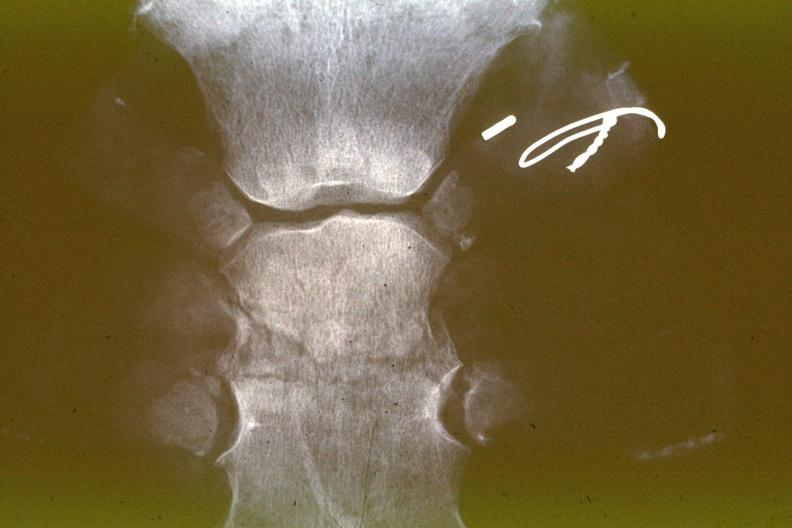does this image show x-ray sternum healing fracture 15 days?
Answer the question using a single word or phrase. Yes 